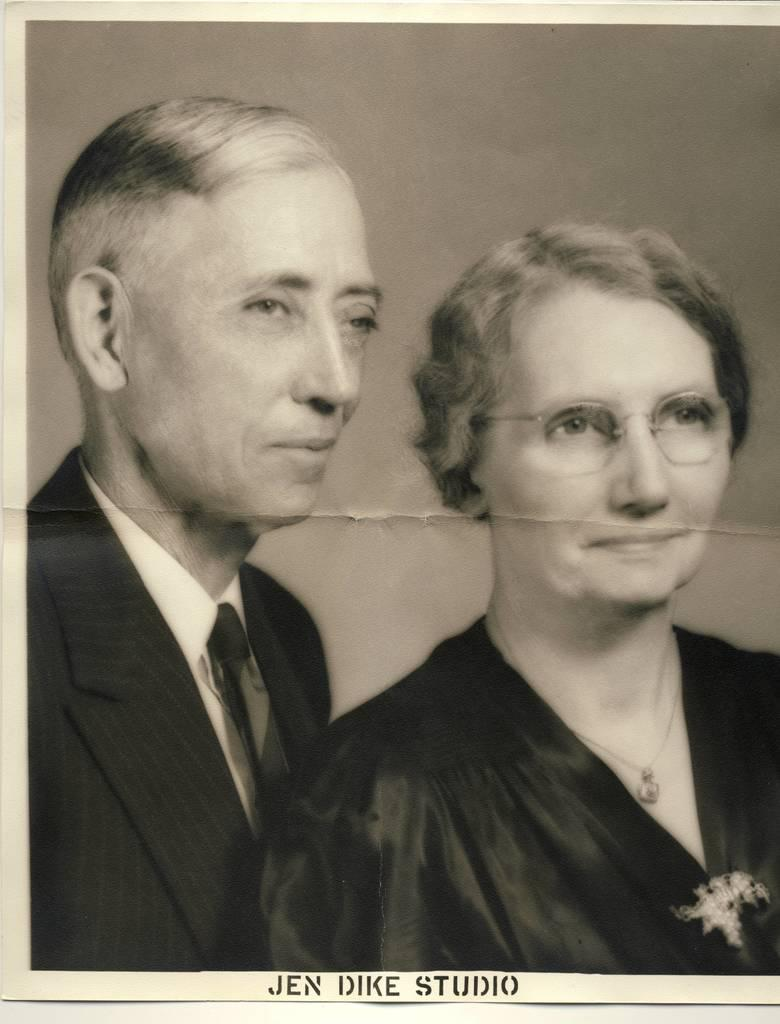What is the color scheme of the poster in the image? The poster is black and white. How many people are depicted on the poster? There are two persons on the poster. What is located at the bottom of the poster? There is text at the bottom of the poster. Can you tell me how many bananas are being held by the persons on the poster? There are no bananas present in the image, as the poster is black and white and only features two persons and text. Is there a ghost visible on the poster? There is no ghost present in the image; the poster only features two persons and text. 